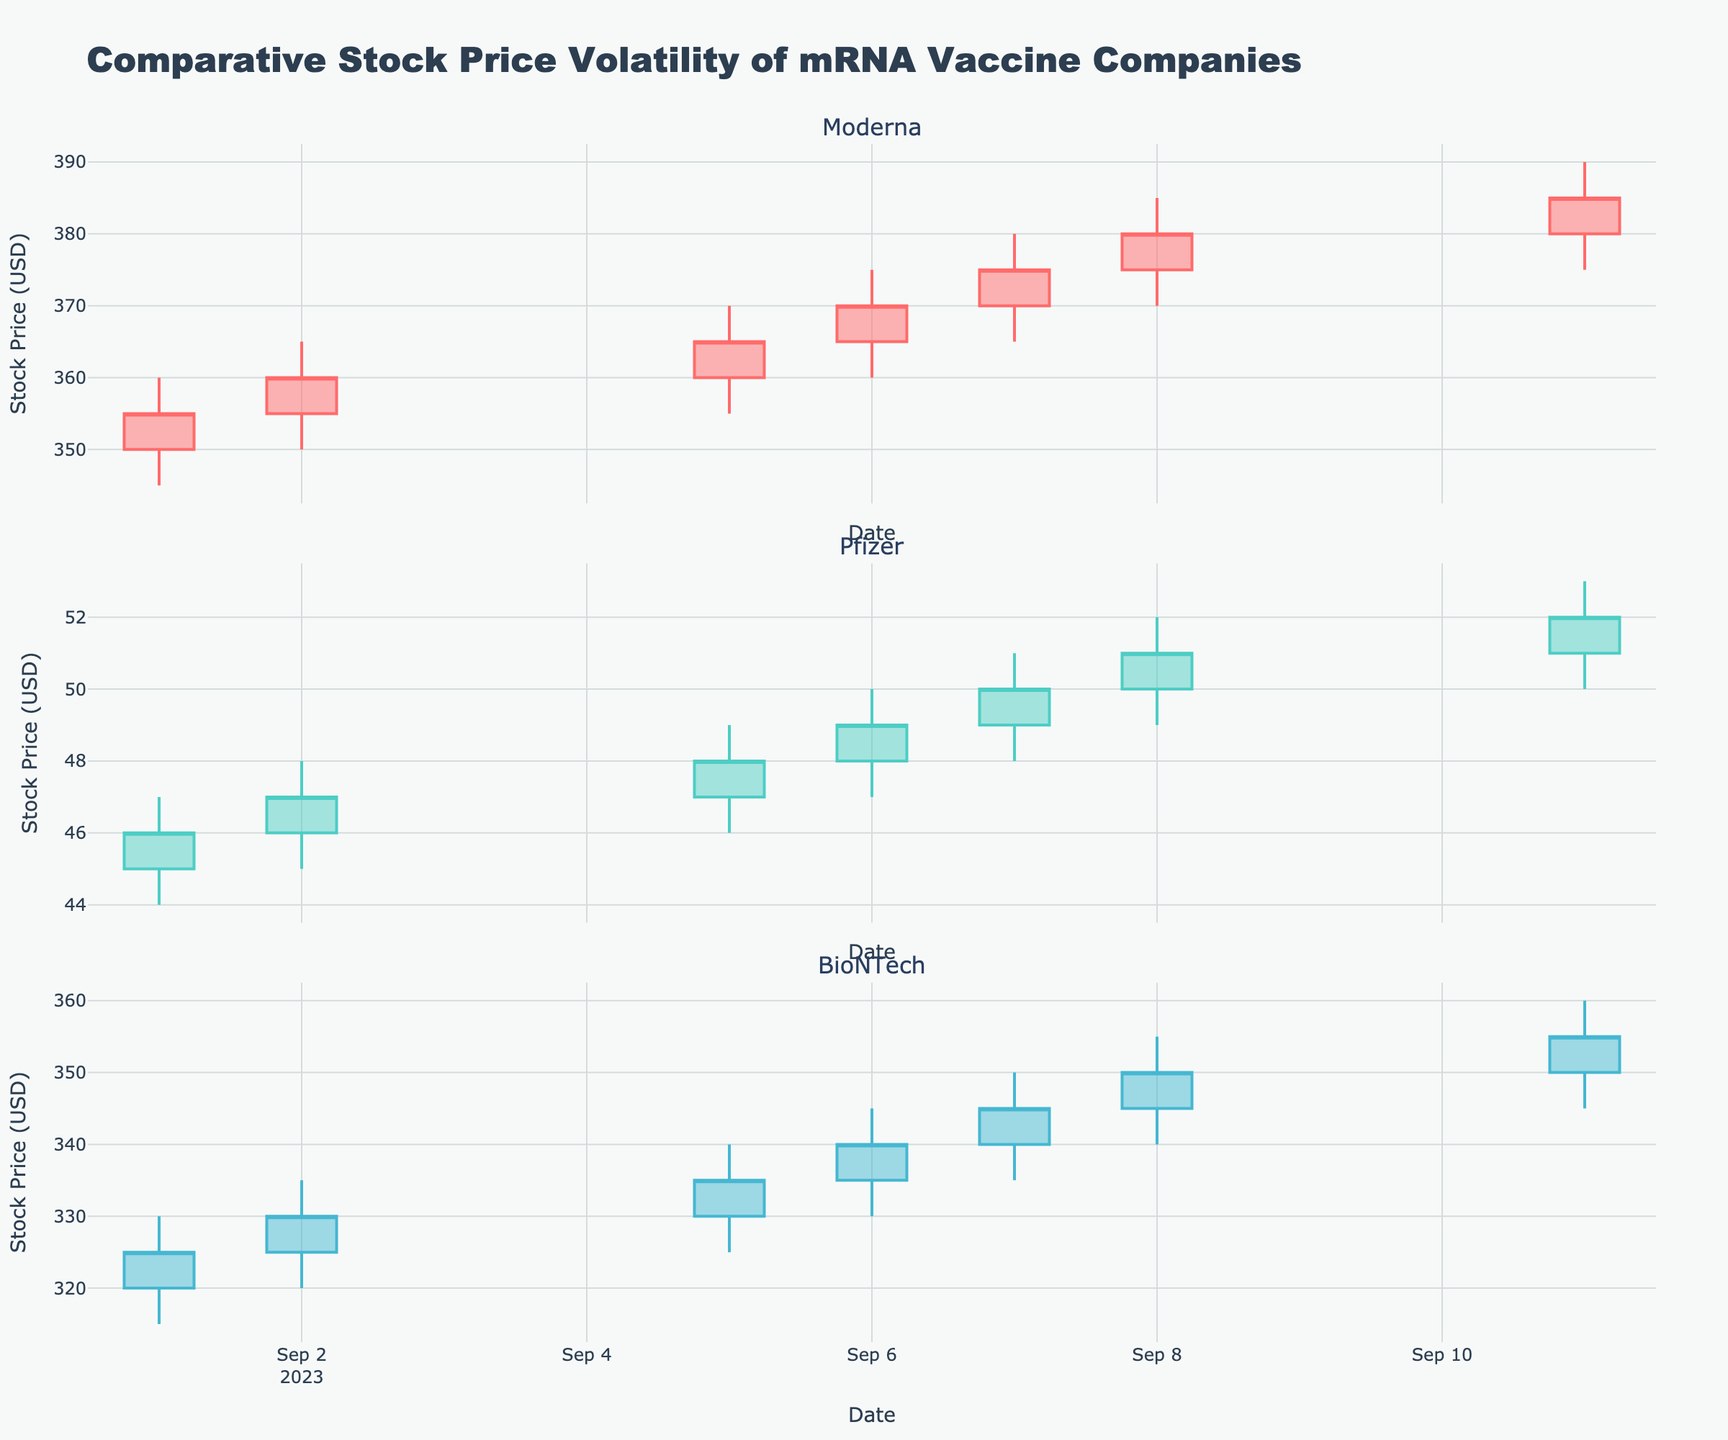What is the title of the figure? The title is usually found at the top center of the figure. In this case, it's mentioned in the layout section of the code, so you will find "Comparative Stock Price Volatility of mRNA Vaccine Companies" as the title.
Answer: Comparative Stock Price Volatility of mRNA Vaccine Companies Which company showed the highest closing price on 2023-09-11? Look at the data points for the date 2023-09-11 and identify the closing prices for Moderna (385), Pfizer (52), and BioNTech (355). Compare these values.
Answer: Moderna On which date did Pfizer show the greatest intraday price range, and what was the monetary range? Calculate the intraday range by subtracting the Low from the High for each date for Pfizer. The date with the highest difference is the date with the greatest intraday range.
Answer: 2023-09-08, $3 How did the closing price of Moderna change from 2023-09-01 to 2023-09-11? Find the closing prices of Moderna on 2023-09-01 (355) and 2023-09-11 (385). Subtract the earlier value from the later value to determine the change.
Answer: Increased by $30 What was the pattern in BioNTech's stock price closure over the dates provided? Identify the closing prices of BioNTech on each date and analyze the sequence: 2023-09-01 (325), 2023-09-02 (330), 2023-09-05 (335), 2023-09-06 (340), 2023-09-07 (345), 2023-09-08 (350), 2023-09-11 (355). This sequence shows an increasing trend.
Answer: Increasing trend Which company's stock shows higher volatility among the three when visualized, and how can you tell? Volatility can be judged by the size of the candlesticks. Larger candlesticks indicate higher volatility. Observe the candlesticks for each company and compare their sizes.
Answer: Moderna Compare the closing prices of all three companies on 2023-09-05. Which company had the lowest closing price? Refer to the data for the date 2023-09-05 and compare the closing prices: Moderna (365), Pfizer (48), BioNTech (335). The lowest among these is for Pfizer.
Answer: Pfizer Between Pfizer and BioNTech, which company had a more consistent closing price trend over the given period? Consistency can be measured by the level of fluctuation. Compare the fluctuation in closing prices for Pfizer and BioNTech across all dates. Pfizer's closing prices: 46, 47, 48, 49, 50, 51, 52. BioNTech's closing prices: 325, 330, 335, 340, 345, 350, 355. Pfizer's fluctuation is smaller, indicating more consistency.
Answer: Pfizer 